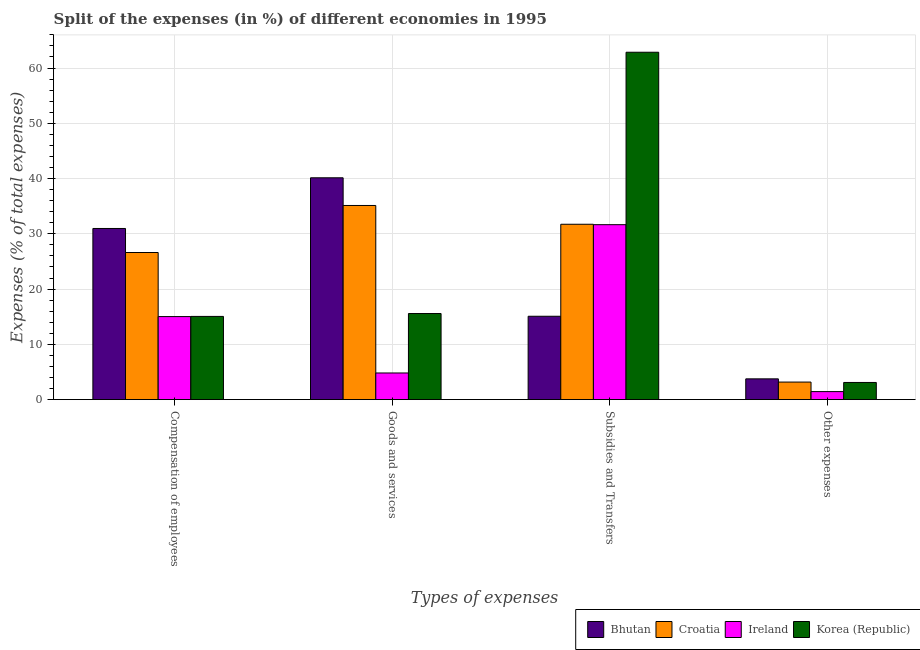Are the number of bars per tick equal to the number of legend labels?
Your answer should be compact. Yes. How many bars are there on the 3rd tick from the left?
Offer a terse response. 4. What is the label of the 4th group of bars from the left?
Keep it short and to the point. Other expenses. What is the percentage of amount spent on other expenses in Croatia?
Provide a short and direct response. 3.17. Across all countries, what is the maximum percentage of amount spent on other expenses?
Keep it short and to the point. 3.76. Across all countries, what is the minimum percentage of amount spent on compensation of employees?
Offer a terse response. 15.02. In which country was the percentage of amount spent on other expenses maximum?
Provide a succinct answer. Bhutan. In which country was the percentage of amount spent on subsidies minimum?
Your answer should be compact. Bhutan. What is the total percentage of amount spent on goods and services in the graph?
Give a very brief answer. 95.66. What is the difference between the percentage of amount spent on compensation of employees in Croatia and that in Korea (Republic)?
Give a very brief answer. 11.56. What is the difference between the percentage of amount spent on goods and services in Croatia and the percentage of amount spent on compensation of employees in Bhutan?
Your answer should be very brief. 4.16. What is the average percentage of amount spent on subsidies per country?
Offer a terse response. 35.33. What is the difference between the percentage of amount spent on compensation of employees and percentage of amount spent on subsidies in Korea (Republic)?
Keep it short and to the point. -47.8. In how many countries, is the percentage of amount spent on goods and services greater than 36 %?
Your answer should be compact. 1. What is the ratio of the percentage of amount spent on goods and services in Ireland to that in Bhutan?
Your answer should be compact. 0.12. Is the percentage of amount spent on compensation of employees in Bhutan less than that in Ireland?
Offer a terse response. No. What is the difference between the highest and the second highest percentage of amount spent on compensation of employees?
Give a very brief answer. 4.35. What is the difference between the highest and the lowest percentage of amount spent on compensation of employees?
Keep it short and to the point. 15.94. In how many countries, is the percentage of amount spent on other expenses greater than the average percentage of amount spent on other expenses taken over all countries?
Keep it short and to the point. 3. Is the sum of the percentage of amount spent on compensation of employees in Croatia and Bhutan greater than the maximum percentage of amount spent on subsidies across all countries?
Keep it short and to the point. No. What does the 2nd bar from the left in Goods and services represents?
Your response must be concise. Croatia. Is it the case that in every country, the sum of the percentage of amount spent on compensation of employees and percentage of amount spent on goods and services is greater than the percentage of amount spent on subsidies?
Provide a short and direct response. No. How many countries are there in the graph?
Keep it short and to the point. 4. Does the graph contain any zero values?
Provide a succinct answer. No. Does the graph contain grids?
Give a very brief answer. Yes. Where does the legend appear in the graph?
Give a very brief answer. Bottom right. How are the legend labels stacked?
Provide a succinct answer. Horizontal. What is the title of the graph?
Your answer should be very brief. Split of the expenses (in %) of different economies in 1995. What is the label or title of the X-axis?
Your answer should be very brief. Types of expenses. What is the label or title of the Y-axis?
Ensure brevity in your answer.  Expenses (% of total expenses). What is the Expenses (% of total expenses) in Bhutan in Compensation of employees?
Your answer should be very brief. 30.97. What is the Expenses (% of total expenses) in Croatia in Compensation of employees?
Offer a terse response. 26.62. What is the Expenses (% of total expenses) in Ireland in Compensation of employees?
Your answer should be compact. 15.02. What is the Expenses (% of total expenses) in Korea (Republic) in Compensation of employees?
Provide a short and direct response. 15.05. What is the Expenses (% of total expenses) in Bhutan in Goods and services?
Your response must be concise. 40.14. What is the Expenses (% of total expenses) in Croatia in Goods and services?
Make the answer very short. 35.13. What is the Expenses (% of total expenses) in Ireland in Goods and services?
Give a very brief answer. 4.82. What is the Expenses (% of total expenses) in Korea (Republic) in Goods and services?
Your answer should be very brief. 15.58. What is the Expenses (% of total expenses) of Bhutan in Subsidies and Transfers?
Provide a short and direct response. 15.08. What is the Expenses (% of total expenses) in Croatia in Subsidies and Transfers?
Provide a succinct answer. 31.73. What is the Expenses (% of total expenses) in Ireland in Subsidies and Transfers?
Make the answer very short. 31.65. What is the Expenses (% of total expenses) of Korea (Republic) in Subsidies and Transfers?
Provide a succinct answer. 62.86. What is the Expenses (% of total expenses) in Bhutan in Other expenses?
Provide a succinct answer. 3.76. What is the Expenses (% of total expenses) in Croatia in Other expenses?
Your response must be concise. 3.17. What is the Expenses (% of total expenses) of Ireland in Other expenses?
Provide a short and direct response. 1.45. What is the Expenses (% of total expenses) in Korea (Republic) in Other expenses?
Give a very brief answer. 3.1. Across all Types of expenses, what is the maximum Expenses (% of total expenses) in Bhutan?
Your answer should be compact. 40.14. Across all Types of expenses, what is the maximum Expenses (% of total expenses) in Croatia?
Ensure brevity in your answer.  35.13. Across all Types of expenses, what is the maximum Expenses (% of total expenses) of Ireland?
Offer a terse response. 31.65. Across all Types of expenses, what is the maximum Expenses (% of total expenses) in Korea (Republic)?
Your answer should be compact. 62.86. Across all Types of expenses, what is the minimum Expenses (% of total expenses) in Bhutan?
Your answer should be very brief. 3.76. Across all Types of expenses, what is the minimum Expenses (% of total expenses) in Croatia?
Provide a succinct answer. 3.17. Across all Types of expenses, what is the minimum Expenses (% of total expenses) in Ireland?
Offer a terse response. 1.45. Across all Types of expenses, what is the minimum Expenses (% of total expenses) of Korea (Republic)?
Your answer should be very brief. 3.1. What is the total Expenses (% of total expenses) of Bhutan in the graph?
Provide a short and direct response. 89.94. What is the total Expenses (% of total expenses) of Croatia in the graph?
Make the answer very short. 96.65. What is the total Expenses (% of total expenses) in Ireland in the graph?
Provide a succinct answer. 52.94. What is the total Expenses (% of total expenses) in Korea (Republic) in the graph?
Your answer should be compact. 96.59. What is the difference between the Expenses (% of total expenses) in Bhutan in Compensation of employees and that in Goods and services?
Your response must be concise. -9.17. What is the difference between the Expenses (% of total expenses) of Croatia in Compensation of employees and that in Goods and services?
Offer a very short reply. -8.51. What is the difference between the Expenses (% of total expenses) in Ireland in Compensation of employees and that in Goods and services?
Provide a succinct answer. 10.21. What is the difference between the Expenses (% of total expenses) of Korea (Republic) in Compensation of employees and that in Goods and services?
Provide a succinct answer. -0.52. What is the difference between the Expenses (% of total expenses) in Bhutan in Compensation of employees and that in Subsidies and Transfers?
Ensure brevity in your answer.  15.89. What is the difference between the Expenses (% of total expenses) in Croatia in Compensation of employees and that in Subsidies and Transfers?
Make the answer very short. -5.11. What is the difference between the Expenses (% of total expenses) of Ireland in Compensation of employees and that in Subsidies and Transfers?
Make the answer very short. -16.63. What is the difference between the Expenses (% of total expenses) of Korea (Republic) in Compensation of employees and that in Subsidies and Transfers?
Your answer should be compact. -47.8. What is the difference between the Expenses (% of total expenses) in Bhutan in Compensation of employees and that in Other expenses?
Your response must be concise. 27.21. What is the difference between the Expenses (% of total expenses) in Croatia in Compensation of employees and that in Other expenses?
Ensure brevity in your answer.  23.45. What is the difference between the Expenses (% of total expenses) of Ireland in Compensation of employees and that in Other expenses?
Your answer should be compact. 13.58. What is the difference between the Expenses (% of total expenses) of Korea (Republic) in Compensation of employees and that in Other expenses?
Give a very brief answer. 11.95. What is the difference between the Expenses (% of total expenses) of Bhutan in Goods and services and that in Subsidies and Transfers?
Provide a succinct answer. 25.06. What is the difference between the Expenses (% of total expenses) in Croatia in Goods and services and that in Subsidies and Transfers?
Make the answer very short. 3.4. What is the difference between the Expenses (% of total expenses) in Ireland in Goods and services and that in Subsidies and Transfers?
Your response must be concise. -26.84. What is the difference between the Expenses (% of total expenses) of Korea (Republic) in Goods and services and that in Subsidies and Transfers?
Provide a short and direct response. -47.28. What is the difference between the Expenses (% of total expenses) in Bhutan in Goods and services and that in Other expenses?
Give a very brief answer. 36.38. What is the difference between the Expenses (% of total expenses) in Croatia in Goods and services and that in Other expenses?
Offer a very short reply. 31.96. What is the difference between the Expenses (% of total expenses) of Ireland in Goods and services and that in Other expenses?
Your response must be concise. 3.37. What is the difference between the Expenses (% of total expenses) of Korea (Republic) in Goods and services and that in Other expenses?
Make the answer very short. 12.47. What is the difference between the Expenses (% of total expenses) of Bhutan in Subsidies and Transfers and that in Other expenses?
Provide a short and direct response. 11.33. What is the difference between the Expenses (% of total expenses) in Croatia in Subsidies and Transfers and that in Other expenses?
Your answer should be compact. 28.56. What is the difference between the Expenses (% of total expenses) in Ireland in Subsidies and Transfers and that in Other expenses?
Ensure brevity in your answer.  30.2. What is the difference between the Expenses (% of total expenses) of Korea (Republic) in Subsidies and Transfers and that in Other expenses?
Ensure brevity in your answer.  59.75. What is the difference between the Expenses (% of total expenses) of Bhutan in Compensation of employees and the Expenses (% of total expenses) of Croatia in Goods and services?
Offer a terse response. -4.16. What is the difference between the Expenses (% of total expenses) of Bhutan in Compensation of employees and the Expenses (% of total expenses) of Ireland in Goods and services?
Ensure brevity in your answer.  26.15. What is the difference between the Expenses (% of total expenses) in Bhutan in Compensation of employees and the Expenses (% of total expenses) in Korea (Republic) in Goods and services?
Ensure brevity in your answer.  15.39. What is the difference between the Expenses (% of total expenses) in Croatia in Compensation of employees and the Expenses (% of total expenses) in Ireland in Goods and services?
Your answer should be very brief. 21.8. What is the difference between the Expenses (% of total expenses) of Croatia in Compensation of employees and the Expenses (% of total expenses) of Korea (Republic) in Goods and services?
Your response must be concise. 11.04. What is the difference between the Expenses (% of total expenses) in Ireland in Compensation of employees and the Expenses (% of total expenses) in Korea (Republic) in Goods and services?
Make the answer very short. -0.55. What is the difference between the Expenses (% of total expenses) of Bhutan in Compensation of employees and the Expenses (% of total expenses) of Croatia in Subsidies and Transfers?
Provide a succinct answer. -0.76. What is the difference between the Expenses (% of total expenses) in Bhutan in Compensation of employees and the Expenses (% of total expenses) in Ireland in Subsidies and Transfers?
Your response must be concise. -0.69. What is the difference between the Expenses (% of total expenses) of Bhutan in Compensation of employees and the Expenses (% of total expenses) of Korea (Republic) in Subsidies and Transfers?
Your answer should be compact. -31.89. What is the difference between the Expenses (% of total expenses) in Croatia in Compensation of employees and the Expenses (% of total expenses) in Ireland in Subsidies and Transfers?
Your answer should be very brief. -5.04. What is the difference between the Expenses (% of total expenses) in Croatia in Compensation of employees and the Expenses (% of total expenses) in Korea (Republic) in Subsidies and Transfers?
Ensure brevity in your answer.  -36.24. What is the difference between the Expenses (% of total expenses) of Ireland in Compensation of employees and the Expenses (% of total expenses) of Korea (Republic) in Subsidies and Transfers?
Your answer should be very brief. -47.83. What is the difference between the Expenses (% of total expenses) of Bhutan in Compensation of employees and the Expenses (% of total expenses) of Croatia in Other expenses?
Offer a very short reply. 27.8. What is the difference between the Expenses (% of total expenses) in Bhutan in Compensation of employees and the Expenses (% of total expenses) in Ireland in Other expenses?
Offer a terse response. 29.52. What is the difference between the Expenses (% of total expenses) of Bhutan in Compensation of employees and the Expenses (% of total expenses) of Korea (Republic) in Other expenses?
Offer a terse response. 27.86. What is the difference between the Expenses (% of total expenses) in Croatia in Compensation of employees and the Expenses (% of total expenses) in Ireland in Other expenses?
Provide a short and direct response. 25.17. What is the difference between the Expenses (% of total expenses) of Croatia in Compensation of employees and the Expenses (% of total expenses) of Korea (Republic) in Other expenses?
Keep it short and to the point. 23.51. What is the difference between the Expenses (% of total expenses) of Ireland in Compensation of employees and the Expenses (% of total expenses) of Korea (Republic) in Other expenses?
Offer a terse response. 11.92. What is the difference between the Expenses (% of total expenses) in Bhutan in Goods and services and the Expenses (% of total expenses) in Croatia in Subsidies and Transfers?
Your answer should be compact. 8.41. What is the difference between the Expenses (% of total expenses) in Bhutan in Goods and services and the Expenses (% of total expenses) in Ireland in Subsidies and Transfers?
Provide a succinct answer. 8.49. What is the difference between the Expenses (% of total expenses) of Bhutan in Goods and services and the Expenses (% of total expenses) of Korea (Republic) in Subsidies and Transfers?
Your answer should be very brief. -22.72. What is the difference between the Expenses (% of total expenses) of Croatia in Goods and services and the Expenses (% of total expenses) of Ireland in Subsidies and Transfers?
Offer a terse response. 3.47. What is the difference between the Expenses (% of total expenses) of Croatia in Goods and services and the Expenses (% of total expenses) of Korea (Republic) in Subsidies and Transfers?
Ensure brevity in your answer.  -27.73. What is the difference between the Expenses (% of total expenses) in Ireland in Goods and services and the Expenses (% of total expenses) in Korea (Republic) in Subsidies and Transfers?
Give a very brief answer. -58.04. What is the difference between the Expenses (% of total expenses) of Bhutan in Goods and services and the Expenses (% of total expenses) of Croatia in Other expenses?
Keep it short and to the point. 36.97. What is the difference between the Expenses (% of total expenses) of Bhutan in Goods and services and the Expenses (% of total expenses) of Ireland in Other expenses?
Provide a short and direct response. 38.69. What is the difference between the Expenses (% of total expenses) in Bhutan in Goods and services and the Expenses (% of total expenses) in Korea (Republic) in Other expenses?
Keep it short and to the point. 37.04. What is the difference between the Expenses (% of total expenses) of Croatia in Goods and services and the Expenses (% of total expenses) of Ireland in Other expenses?
Your response must be concise. 33.68. What is the difference between the Expenses (% of total expenses) in Croatia in Goods and services and the Expenses (% of total expenses) in Korea (Republic) in Other expenses?
Keep it short and to the point. 32.02. What is the difference between the Expenses (% of total expenses) in Ireland in Goods and services and the Expenses (% of total expenses) in Korea (Republic) in Other expenses?
Provide a succinct answer. 1.71. What is the difference between the Expenses (% of total expenses) in Bhutan in Subsidies and Transfers and the Expenses (% of total expenses) in Croatia in Other expenses?
Make the answer very short. 11.91. What is the difference between the Expenses (% of total expenses) of Bhutan in Subsidies and Transfers and the Expenses (% of total expenses) of Ireland in Other expenses?
Make the answer very short. 13.63. What is the difference between the Expenses (% of total expenses) of Bhutan in Subsidies and Transfers and the Expenses (% of total expenses) of Korea (Republic) in Other expenses?
Your answer should be compact. 11.98. What is the difference between the Expenses (% of total expenses) in Croatia in Subsidies and Transfers and the Expenses (% of total expenses) in Ireland in Other expenses?
Offer a very short reply. 30.28. What is the difference between the Expenses (% of total expenses) in Croatia in Subsidies and Transfers and the Expenses (% of total expenses) in Korea (Republic) in Other expenses?
Provide a succinct answer. 28.63. What is the difference between the Expenses (% of total expenses) of Ireland in Subsidies and Transfers and the Expenses (% of total expenses) of Korea (Republic) in Other expenses?
Make the answer very short. 28.55. What is the average Expenses (% of total expenses) in Bhutan per Types of expenses?
Ensure brevity in your answer.  22.49. What is the average Expenses (% of total expenses) of Croatia per Types of expenses?
Ensure brevity in your answer.  24.16. What is the average Expenses (% of total expenses) of Ireland per Types of expenses?
Give a very brief answer. 13.24. What is the average Expenses (% of total expenses) in Korea (Republic) per Types of expenses?
Make the answer very short. 24.15. What is the difference between the Expenses (% of total expenses) in Bhutan and Expenses (% of total expenses) in Croatia in Compensation of employees?
Give a very brief answer. 4.35. What is the difference between the Expenses (% of total expenses) of Bhutan and Expenses (% of total expenses) of Ireland in Compensation of employees?
Provide a succinct answer. 15.94. What is the difference between the Expenses (% of total expenses) in Bhutan and Expenses (% of total expenses) in Korea (Republic) in Compensation of employees?
Your response must be concise. 15.91. What is the difference between the Expenses (% of total expenses) in Croatia and Expenses (% of total expenses) in Ireland in Compensation of employees?
Make the answer very short. 11.59. What is the difference between the Expenses (% of total expenses) of Croatia and Expenses (% of total expenses) of Korea (Republic) in Compensation of employees?
Give a very brief answer. 11.56. What is the difference between the Expenses (% of total expenses) of Ireland and Expenses (% of total expenses) of Korea (Republic) in Compensation of employees?
Your response must be concise. -0.03. What is the difference between the Expenses (% of total expenses) in Bhutan and Expenses (% of total expenses) in Croatia in Goods and services?
Give a very brief answer. 5.01. What is the difference between the Expenses (% of total expenses) in Bhutan and Expenses (% of total expenses) in Ireland in Goods and services?
Offer a very short reply. 35.32. What is the difference between the Expenses (% of total expenses) in Bhutan and Expenses (% of total expenses) in Korea (Republic) in Goods and services?
Your response must be concise. 24.56. What is the difference between the Expenses (% of total expenses) in Croatia and Expenses (% of total expenses) in Ireland in Goods and services?
Your answer should be very brief. 30.31. What is the difference between the Expenses (% of total expenses) of Croatia and Expenses (% of total expenses) of Korea (Republic) in Goods and services?
Make the answer very short. 19.55. What is the difference between the Expenses (% of total expenses) of Ireland and Expenses (% of total expenses) of Korea (Republic) in Goods and services?
Provide a succinct answer. -10.76. What is the difference between the Expenses (% of total expenses) in Bhutan and Expenses (% of total expenses) in Croatia in Subsidies and Transfers?
Your answer should be compact. -16.65. What is the difference between the Expenses (% of total expenses) in Bhutan and Expenses (% of total expenses) in Ireland in Subsidies and Transfers?
Provide a short and direct response. -16.57. What is the difference between the Expenses (% of total expenses) of Bhutan and Expenses (% of total expenses) of Korea (Republic) in Subsidies and Transfers?
Provide a succinct answer. -47.78. What is the difference between the Expenses (% of total expenses) of Croatia and Expenses (% of total expenses) of Ireland in Subsidies and Transfers?
Ensure brevity in your answer.  0.08. What is the difference between the Expenses (% of total expenses) of Croatia and Expenses (% of total expenses) of Korea (Republic) in Subsidies and Transfers?
Provide a succinct answer. -31.13. What is the difference between the Expenses (% of total expenses) of Ireland and Expenses (% of total expenses) of Korea (Republic) in Subsidies and Transfers?
Offer a terse response. -31.2. What is the difference between the Expenses (% of total expenses) of Bhutan and Expenses (% of total expenses) of Croatia in Other expenses?
Your answer should be compact. 0.58. What is the difference between the Expenses (% of total expenses) in Bhutan and Expenses (% of total expenses) in Ireland in Other expenses?
Your answer should be compact. 2.31. What is the difference between the Expenses (% of total expenses) of Bhutan and Expenses (% of total expenses) of Korea (Republic) in Other expenses?
Offer a terse response. 0.65. What is the difference between the Expenses (% of total expenses) of Croatia and Expenses (% of total expenses) of Ireland in Other expenses?
Your answer should be very brief. 1.72. What is the difference between the Expenses (% of total expenses) in Croatia and Expenses (% of total expenses) in Korea (Republic) in Other expenses?
Make the answer very short. 0.07. What is the difference between the Expenses (% of total expenses) in Ireland and Expenses (% of total expenses) in Korea (Republic) in Other expenses?
Provide a succinct answer. -1.65. What is the ratio of the Expenses (% of total expenses) in Bhutan in Compensation of employees to that in Goods and services?
Provide a succinct answer. 0.77. What is the ratio of the Expenses (% of total expenses) of Croatia in Compensation of employees to that in Goods and services?
Offer a very short reply. 0.76. What is the ratio of the Expenses (% of total expenses) in Ireland in Compensation of employees to that in Goods and services?
Offer a terse response. 3.12. What is the ratio of the Expenses (% of total expenses) in Korea (Republic) in Compensation of employees to that in Goods and services?
Your answer should be very brief. 0.97. What is the ratio of the Expenses (% of total expenses) in Bhutan in Compensation of employees to that in Subsidies and Transfers?
Ensure brevity in your answer.  2.05. What is the ratio of the Expenses (% of total expenses) in Croatia in Compensation of employees to that in Subsidies and Transfers?
Your answer should be compact. 0.84. What is the ratio of the Expenses (% of total expenses) of Ireland in Compensation of employees to that in Subsidies and Transfers?
Your answer should be very brief. 0.47. What is the ratio of the Expenses (% of total expenses) in Korea (Republic) in Compensation of employees to that in Subsidies and Transfers?
Give a very brief answer. 0.24. What is the ratio of the Expenses (% of total expenses) in Bhutan in Compensation of employees to that in Other expenses?
Offer a terse response. 8.25. What is the ratio of the Expenses (% of total expenses) of Croatia in Compensation of employees to that in Other expenses?
Provide a succinct answer. 8.39. What is the ratio of the Expenses (% of total expenses) of Ireland in Compensation of employees to that in Other expenses?
Your answer should be very brief. 10.37. What is the ratio of the Expenses (% of total expenses) in Korea (Republic) in Compensation of employees to that in Other expenses?
Ensure brevity in your answer.  4.85. What is the ratio of the Expenses (% of total expenses) of Bhutan in Goods and services to that in Subsidies and Transfers?
Your answer should be compact. 2.66. What is the ratio of the Expenses (% of total expenses) in Croatia in Goods and services to that in Subsidies and Transfers?
Make the answer very short. 1.11. What is the ratio of the Expenses (% of total expenses) of Ireland in Goods and services to that in Subsidies and Transfers?
Ensure brevity in your answer.  0.15. What is the ratio of the Expenses (% of total expenses) in Korea (Republic) in Goods and services to that in Subsidies and Transfers?
Provide a succinct answer. 0.25. What is the ratio of the Expenses (% of total expenses) in Bhutan in Goods and services to that in Other expenses?
Keep it short and to the point. 10.69. What is the ratio of the Expenses (% of total expenses) in Croatia in Goods and services to that in Other expenses?
Give a very brief answer. 11.07. What is the ratio of the Expenses (% of total expenses) of Ireland in Goods and services to that in Other expenses?
Make the answer very short. 3.33. What is the ratio of the Expenses (% of total expenses) of Korea (Republic) in Goods and services to that in Other expenses?
Your response must be concise. 5.02. What is the ratio of the Expenses (% of total expenses) in Bhutan in Subsidies and Transfers to that in Other expenses?
Your answer should be compact. 4.02. What is the ratio of the Expenses (% of total expenses) in Croatia in Subsidies and Transfers to that in Other expenses?
Provide a short and direct response. 10. What is the ratio of the Expenses (% of total expenses) of Ireland in Subsidies and Transfers to that in Other expenses?
Your response must be concise. 21.85. What is the ratio of the Expenses (% of total expenses) in Korea (Republic) in Subsidies and Transfers to that in Other expenses?
Your answer should be very brief. 20.25. What is the difference between the highest and the second highest Expenses (% of total expenses) of Bhutan?
Offer a terse response. 9.17. What is the difference between the highest and the second highest Expenses (% of total expenses) of Croatia?
Your response must be concise. 3.4. What is the difference between the highest and the second highest Expenses (% of total expenses) of Ireland?
Make the answer very short. 16.63. What is the difference between the highest and the second highest Expenses (% of total expenses) of Korea (Republic)?
Make the answer very short. 47.28. What is the difference between the highest and the lowest Expenses (% of total expenses) of Bhutan?
Your answer should be compact. 36.38. What is the difference between the highest and the lowest Expenses (% of total expenses) in Croatia?
Provide a short and direct response. 31.96. What is the difference between the highest and the lowest Expenses (% of total expenses) of Ireland?
Give a very brief answer. 30.2. What is the difference between the highest and the lowest Expenses (% of total expenses) in Korea (Republic)?
Make the answer very short. 59.75. 